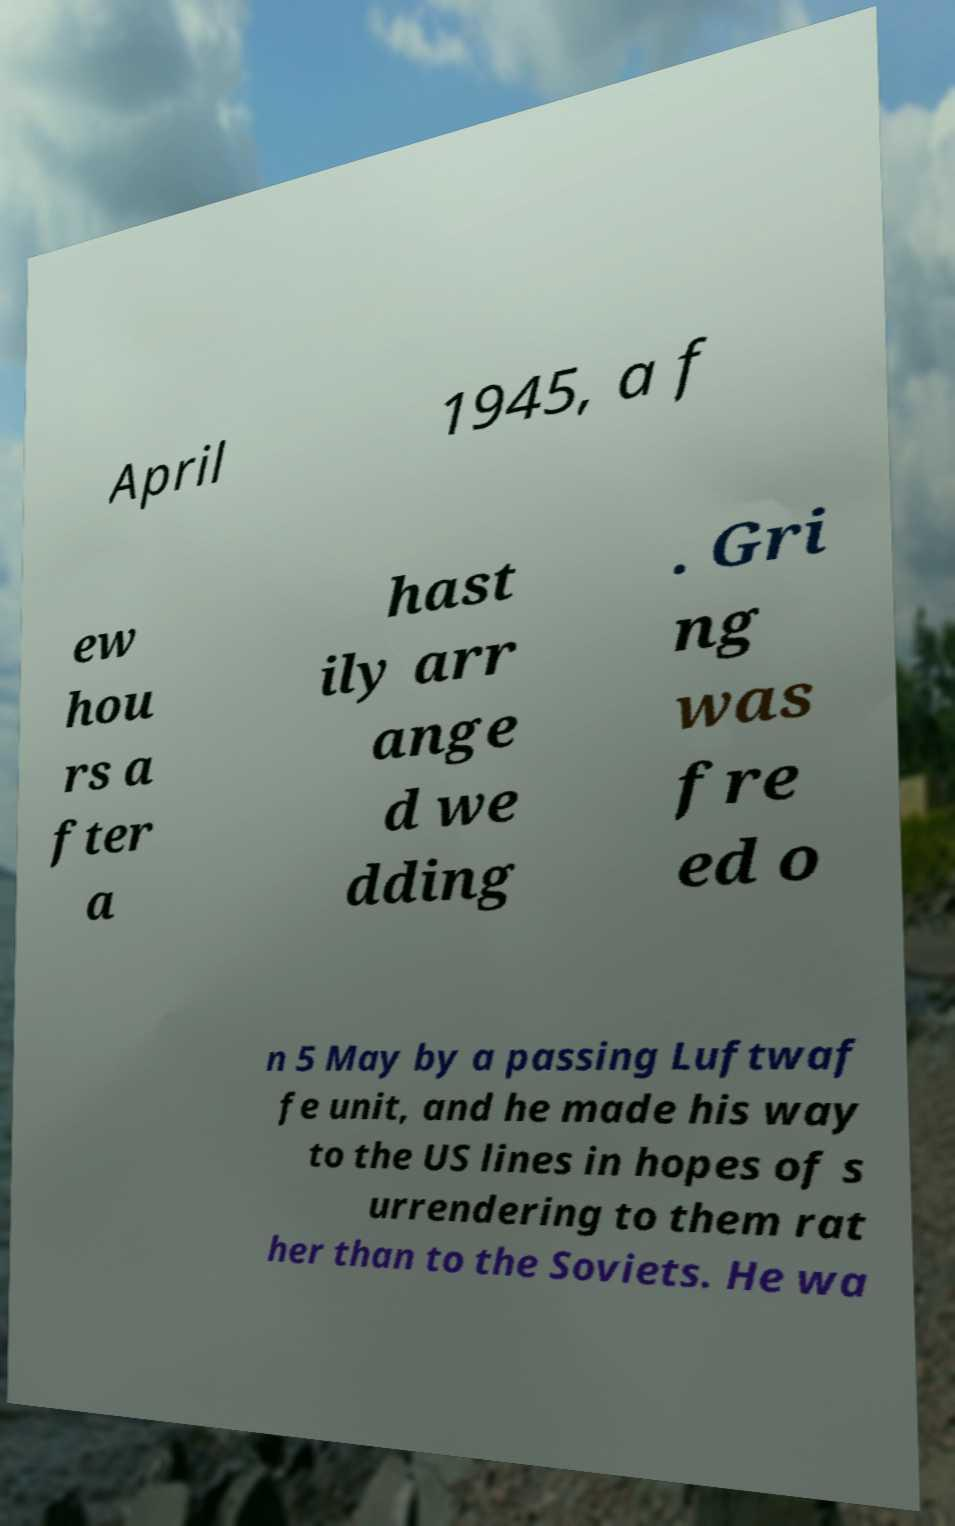Could you assist in decoding the text presented in this image and type it out clearly? April 1945, a f ew hou rs a fter a hast ily arr ange d we dding . Gri ng was fre ed o n 5 May by a passing Luftwaf fe unit, and he made his way to the US lines in hopes of s urrendering to them rat her than to the Soviets. He wa 